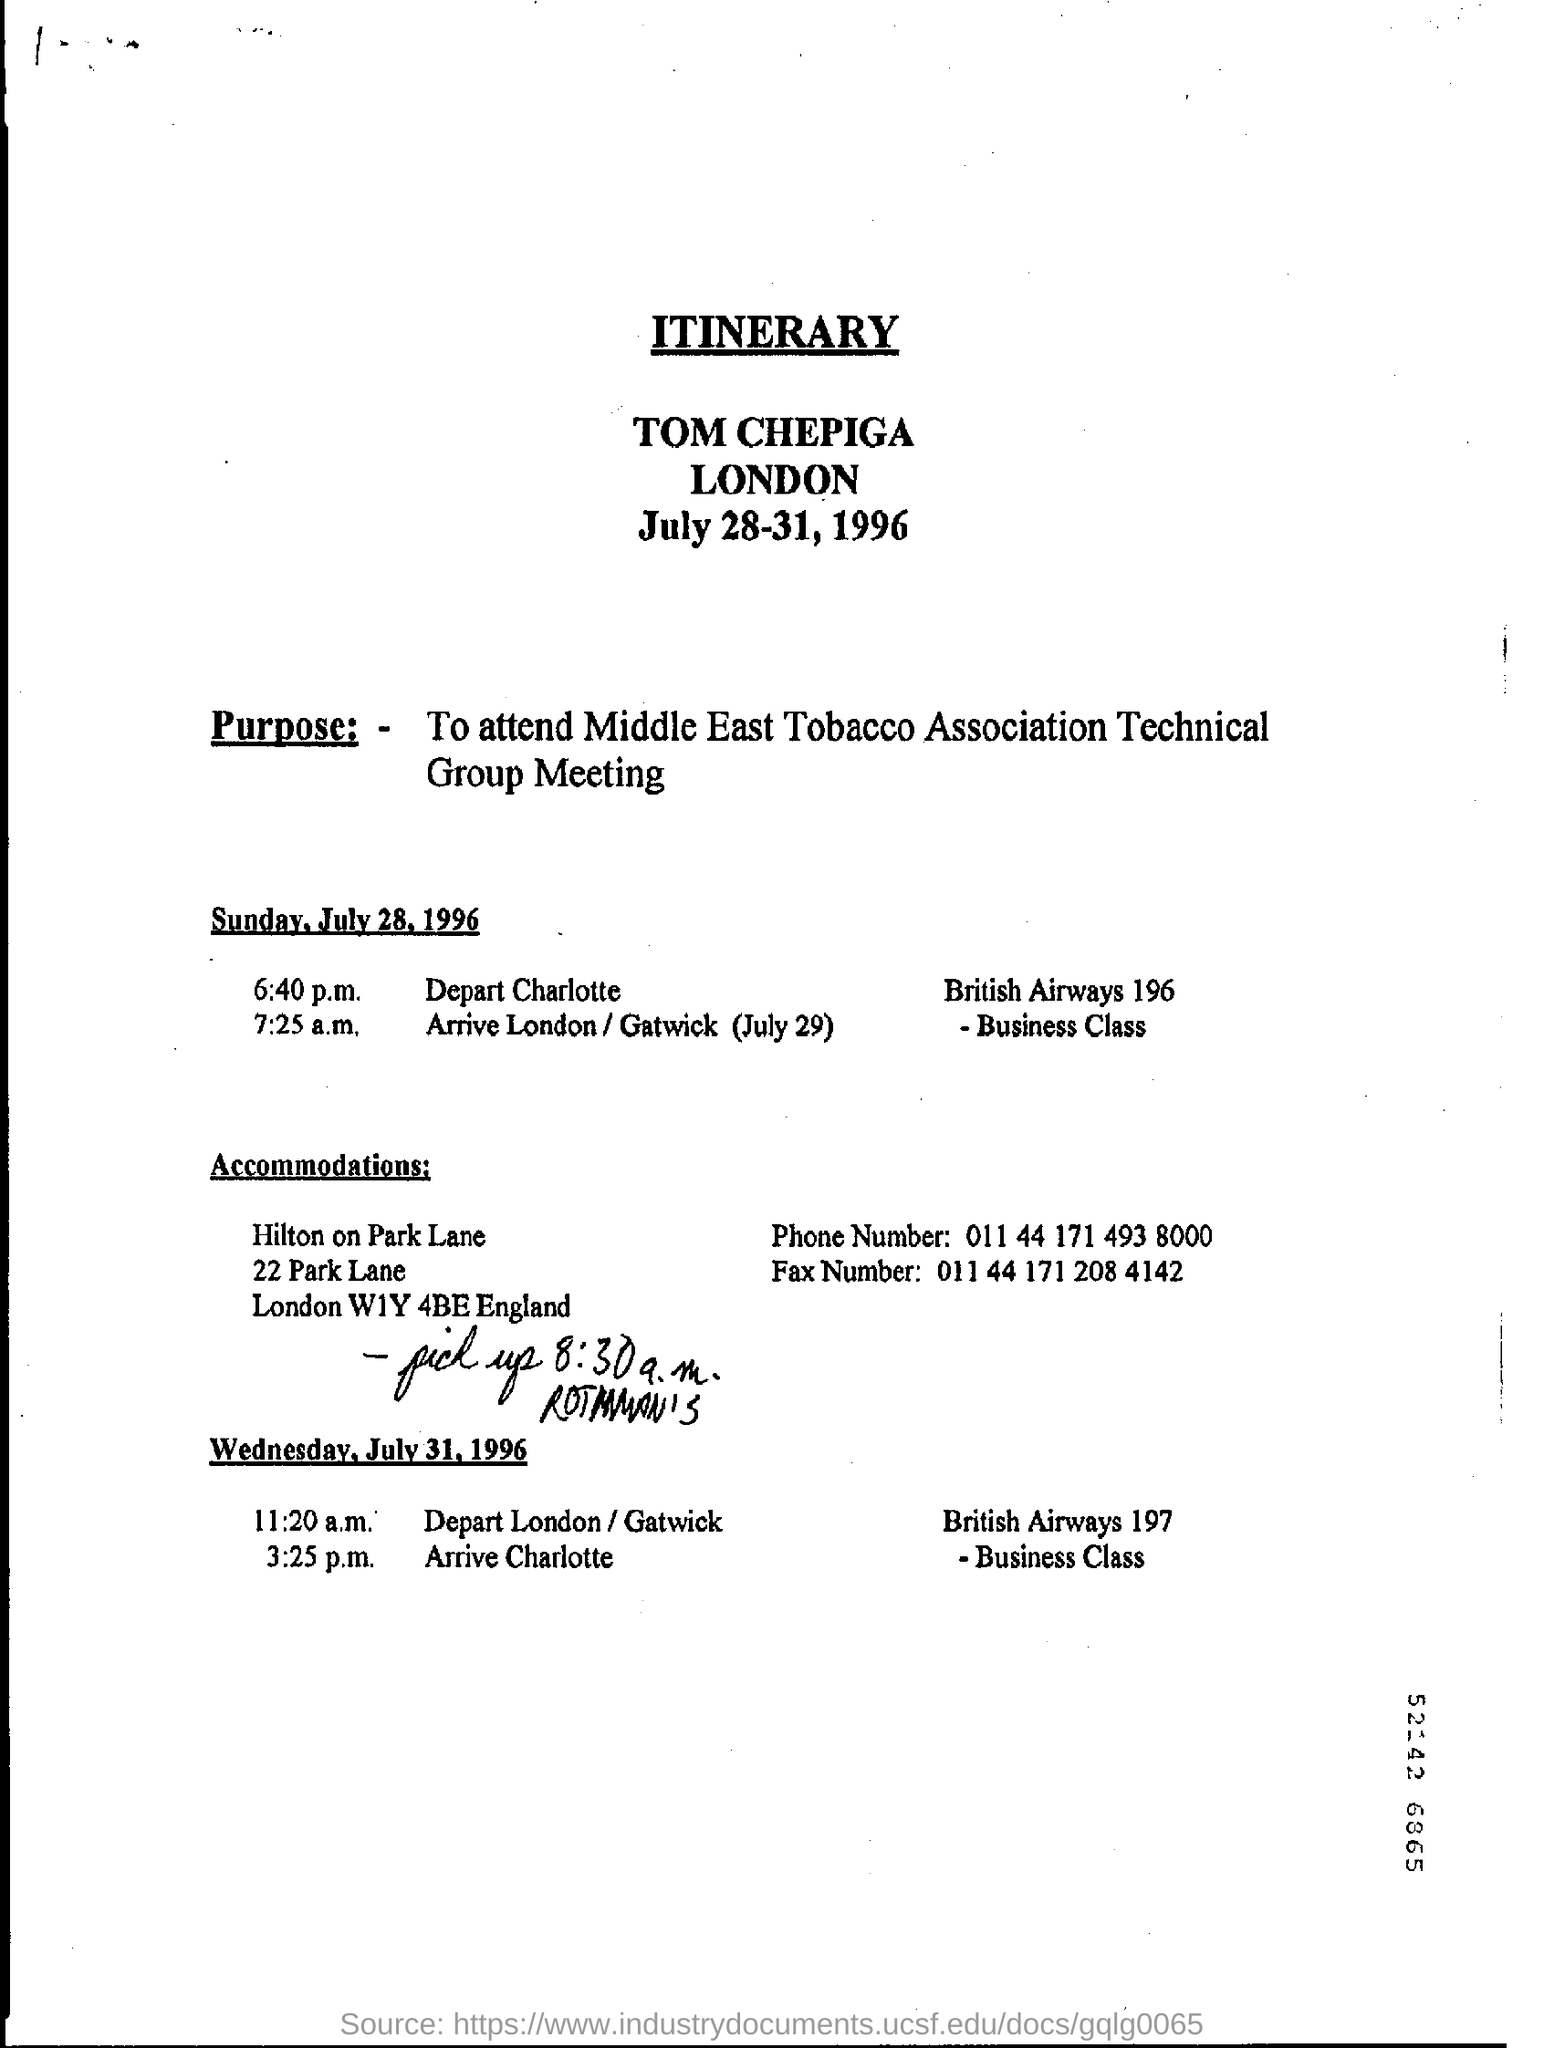What is the Purpose?
Give a very brief answer. To attend Middle East Tobacco Association Technical Group Meeting. 